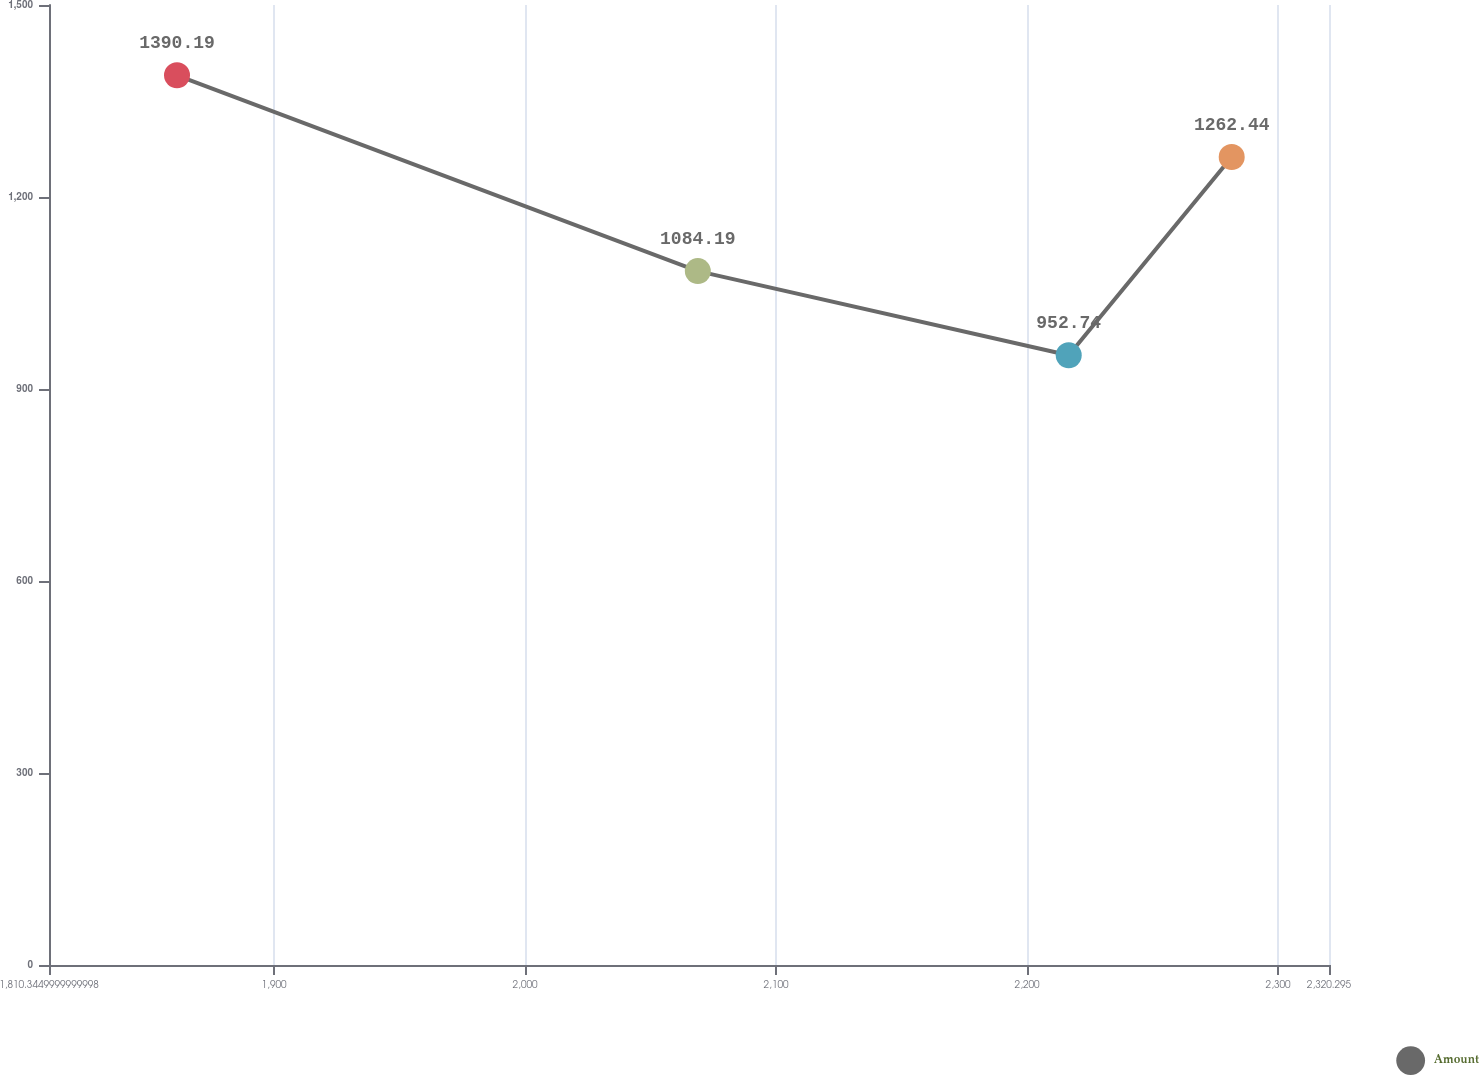Convert chart to OTSL. <chart><loc_0><loc_0><loc_500><loc_500><line_chart><ecel><fcel>Amount<nl><fcel>1861.34<fcel>1390.19<nl><fcel>2068.84<fcel>1084.19<nl><fcel>2216.6<fcel>952.74<nl><fcel>2281.53<fcel>1262.44<nl><fcel>2371.29<fcel>1306.18<nl></chart> 